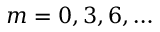Convert formula to latex. <formula><loc_0><loc_0><loc_500><loc_500>m = 0 , 3 , 6 , \dots</formula> 